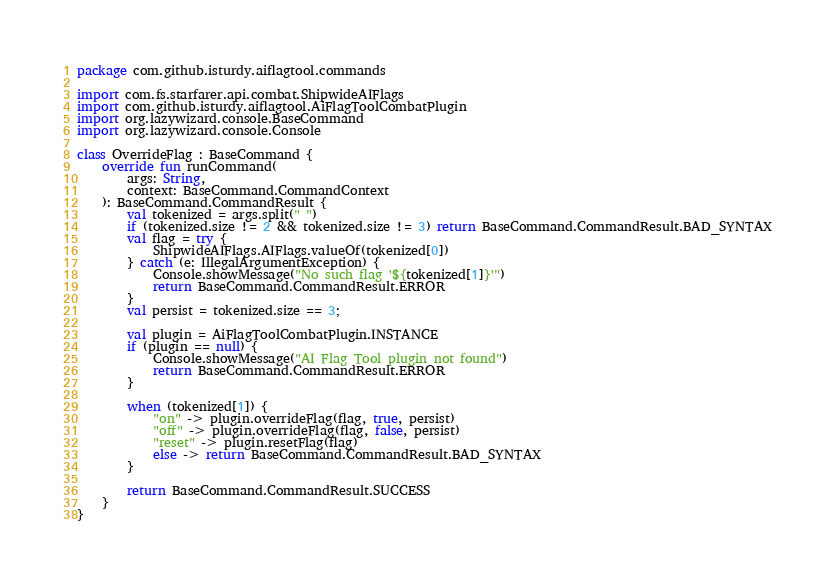<code> <loc_0><loc_0><loc_500><loc_500><_Kotlin_>package com.github.isturdy.aiflagtool.commands

import com.fs.starfarer.api.combat.ShipwideAIFlags
import com.github.isturdy.aiflagtool.AiFlagToolCombatPlugin
import org.lazywizard.console.BaseCommand
import org.lazywizard.console.Console

class OverrideFlag : BaseCommand {
    override fun runCommand(
        args: String,
        context: BaseCommand.CommandContext
    ): BaseCommand.CommandResult {
        val tokenized = args.split(" ")
        if (tokenized.size != 2 && tokenized.size != 3) return BaseCommand.CommandResult.BAD_SYNTAX
        val flag = try {
            ShipwideAIFlags.AIFlags.valueOf(tokenized[0])
        } catch (e: IllegalArgumentException) {
            Console.showMessage("No such flag '${tokenized[1]}'")
            return BaseCommand.CommandResult.ERROR
        }
        val persist = tokenized.size == 3;

        val plugin = AiFlagToolCombatPlugin.INSTANCE
        if (plugin == null) {
            Console.showMessage("AI Flag Tool plugin not found")
            return BaseCommand.CommandResult.ERROR
        }

        when (tokenized[1]) {
            "on" -> plugin.overrideFlag(flag, true, persist)
            "off" -> plugin.overrideFlag(flag, false, persist)
            "reset" -> plugin.resetFlag(flag)
            else -> return BaseCommand.CommandResult.BAD_SYNTAX
        }

        return BaseCommand.CommandResult.SUCCESS
    }
}</code> 